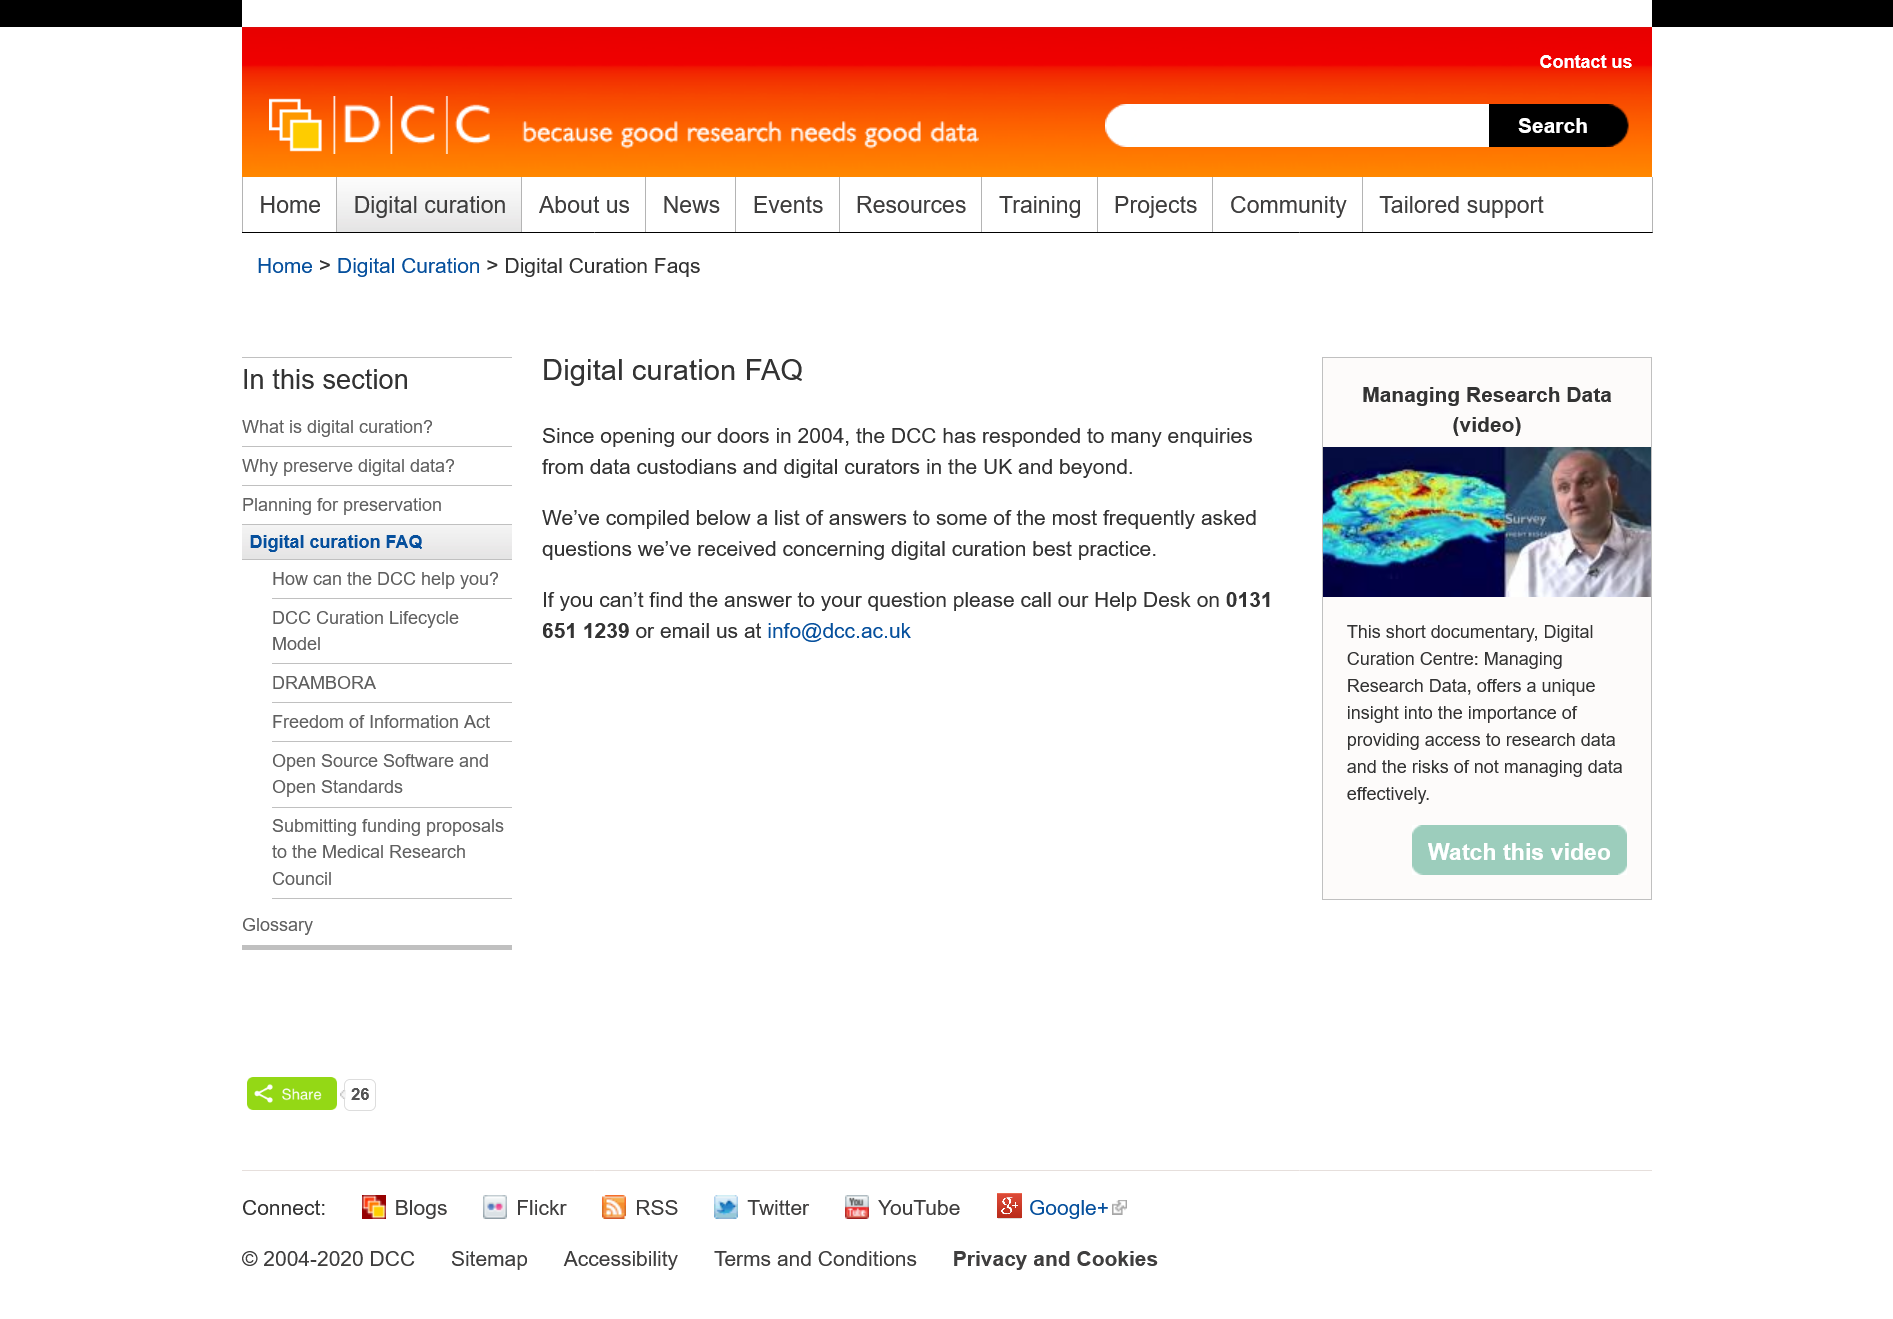Mention a couple of crucial points in this snapshot. The phone number to the DCC Help Desk is 0131 651 1239. The Dubai CommerCity (DCC) opened in 2004. The DCC email is info@dcc.ac.uk. 